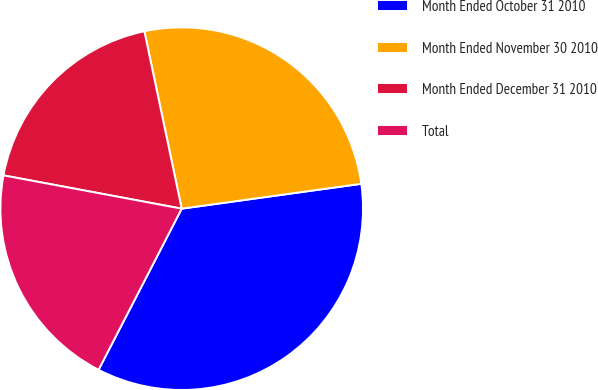Convert chart to OTSL. <chart><loc_0><loc_0><loc_500><loc_500><pie_chart><fcel>Month Ended October 31 2010<fcel>Month Ended November 30 2010<fcel>Month Ended December 31 2010<fcel>Total<nl><fcel>34.77%<fcel>26.11%<fcel>18.76%<fcel>20.36%<nl></chart> 